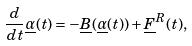Convert formula to latex. <formula><loc_0><loc_0><loc_500><loc_500>\frac { d } { d t } \underline { \alpha } ( t ) = - \underline { B } ( \underline { \alpha } ( t ) ) + \underline { F } ^ { R } ( t ) ,</formula> 